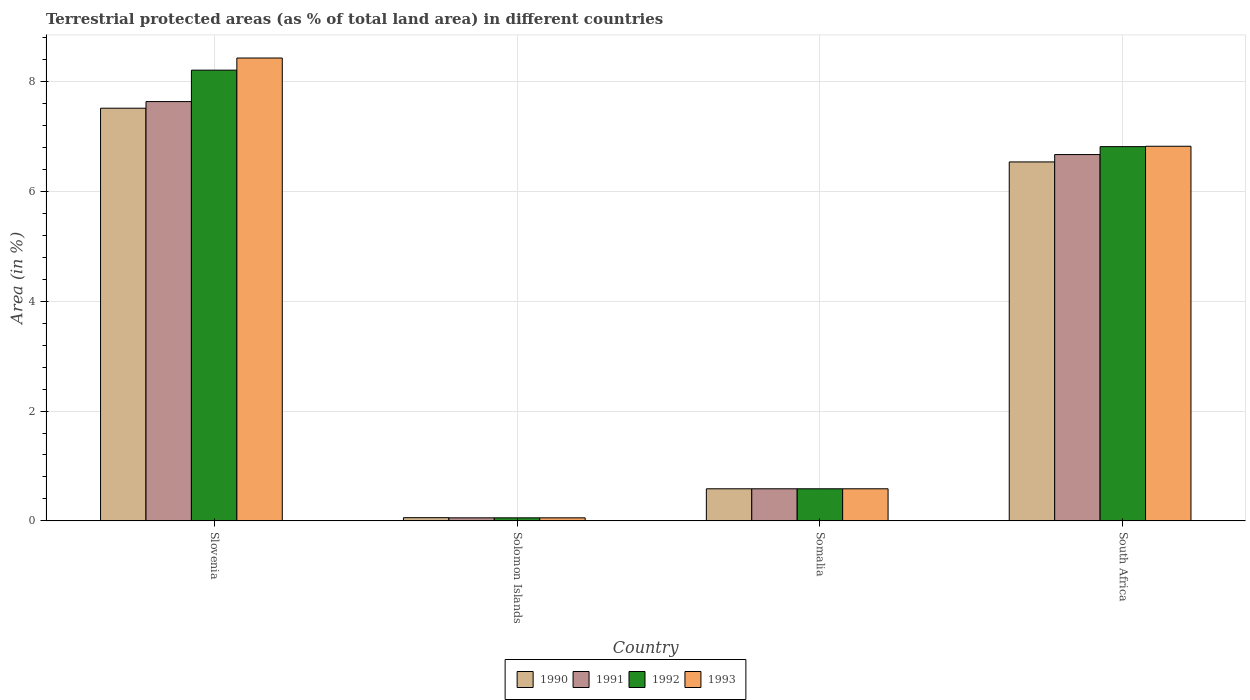How many different coloured bars are there?
Your answer should be very brief. 4. How many groups of bars are there?
Offer a very short reply. 4. Are the number of bars on each tick of the X-axis equal?
Keep it short and to the point. Yes. What is the label of the 3rd group of bars from the left?
Make the answer very short. Somalia. In how many cases, is the number of bars for a given country not equal to the number of legend labels?
Provide a short and direct response. 0. What is the percentage of terrestrial protected land in 1990 in Solomon Islands?
Make the answer very short. 0.06. Across all countries, what is the maximum percentage of terrestrial protected land in 1992?
Keep it short and to the point. 8.21. Across all countries, what is the minimum percentage of terrestrial protected land in 1993?
Provide a short and direct response. 0.05. In which country was the percentage of terrestrial protected land in 1991 maximum?
Ensure brevity in your answer.  Slovenia. In which country was the percentage of terrestrial protected land in 1990 minimum?
Provide a short and direct response. Solomon Islands. What is the total percentage of terrestrial protected land in 1992 in the graph?
Offer a terse response. 15.67. What is the difference between the percentage of terrestrial protected land in 1991 in Solomon Islands and that in Somalia?
Provide a short and direct response. -0.53. What is the difference between the percentage of terrestrial protected land in 1990 in Slovenia and the percentage of terrestrial protected land in 1992 in Solomon Islands?
Your answer should be compact. 7.46. What is the average percentage of terrestrial protected land in 1990 per country?
Give a very brief answer. 3.68. What is the difference between the percentage of terrestrial protected land of/in 1990 and percentage of terrestrial protected land of/in 1991 in Somalia?
Keep it short and to the point. 3.1764990611193866e-6. What is the ratio of the percentage of terrestrial protected land in 1992 in Solomon Islands to that in South Africa?
Provide a succinct answer. 0.01. Is the difference between the percentage of terrestrial protected land in 1990 in Slovenia and South Africa greater than the difference between the percentage of terrestrial protected land in 1991 in Slovenia and South Africa?
Your answer should be very brief. Yes. What is the difference between the highest and the second highest percentage of terrestrial protected land in 1992?
Your response must be concise. 7.63. What is the difference between the highest and the lowest percentage of terrestrial protected land in 1990?
Keep it short and to the point. 7.46. In how many countries, is the percentage of terrestrial protected land in 1992 greater than the average percentage of terrestrial protected land in 1992 taken over all countries?
Offer a very short reply. 2. Is the sum of the percentage of terrestrial protected land in 1993 in Slovenia and Solomon Islands greater than the maximum percentage of terrestrial protected land in 1991 across all countries?
Your answer should be very brief. Yes. What does the 4th bar from the left in Solomon Islands represents?
Your response must be concise. 1993. How many bars are there?
Provide a succinct answer. 16. What is the difference between two consecutive major ticks on the Y-axis?
Your response must be concise. 2. Does the graph contain any zero values?
Your answer should be very brief. No. Does the graph contain grids?
Give a very brief answer. Yes. How many legend labels are there?
Your response must be concise. 4. How are the legend labels stacked?
Provide a short and direct response. Horizontal. What is the title of the graph?
Provide a succinct answer. Terrestrial protected areas (as % of total land area) in different countries. Does "2011" appear as one of the legend labels in the graph?
Make the answer very short. No. What is the label or title of the Y-axis?
Your answer should be compact. Area (in %). What is the Area (in %) in 1990 in Slovenia?
Ensure brevity in your answer.  7.52. What is the Area (in %) of 1991 in Slovenia?
Keep it short and to the point. 7.64. What is the Area (in %) in 1992 in Slovenia?
Make the answer very short. 8.21. What is the Area (in %) of 1993 in Slovenia?
Ensure brevity in your answer.  8.43. What is the Area (in %) of 1990 in Solomon Islands?
Your answer should be compact. 0.06. What is the Area (in %) in 1991 in Solomon Islands?
Your answer should be very brief. 0.05. What is the Area (in %) of 1992 in Solomon Islands?
Your answer should be very brief. 0.05. What is the Area (in %) of 1993 in Solomon Islands?
Your answer should be compact. 0.05. What is the Area (in %) in 1990 in Somalia?
Provide a succinct answer. 0.58. What is the Area (in %) of 1991 in Somalia?
Ensure brevity in your answer.  0.58. What is the Area (in %) of 1992 in Somalia?
Offer a terse response. 0.58. What is the Area (in %) of 1993 in Somalia?
Offer a terse response. 0.58. What is the Area (in %) in 1990 in South Africa?
Offer a very short reply. 6.54. What is the Area (in %) in 1991 in South Africa?
Ensure brevity in your answer.  6.67. What is the Area (in %) of 1992 in South Africa?
Keep it short and to the point. 6.82. What is the Area (in %) in 1993 in South Africa?
Your answer should be very brief. 6.83. Across all countries, what is the maximum Area (in %) of 1990?
Provide a succinct answer. 7.52. Across all countries, what is the maximum Area (in %) in 1991?
Offer a terse response. 7.64. Across all countries, what is the maximum Area (in %) of 1992?
Provide a succinct answer. 8.21. Across all countries, what is the maximum Area (in %) of 1993?
Provide a short and direct response. 8.43. Across all countries, what is the minimum Area (in %) of 1990?
Provide a short and direct response. 0.06. Across all countries, what is the minimum Area (in %) of 1991?
Provide a short and direct response. 0.05. Across all countries, what is the minimum Area (in %) in 1992?
Make the answer very short. 0.05. Across all countries, what is the minimum Area (in %) of 1993?
Your answer should be very brief. 0.05. What is the total Area (in %) in 1990 in the graph?
Your answer should be compact. 14.7. What is the total Area (in %) in 1991 in the graph?
Your answer should be very brief. 14.95. What is the total Area (in %) in 1992 in the graph?
Your answer should be very brief. 15.67. What is the total Area (in %) of 1993 in the graph?
Provide a short and direct response. 15.9. What is the difference between the Area (in %) of 1990 in Slovenia and that in Solomon Islands?
Your answer should be very brief. 7.46. What is the difference between the Area (in %) in 1991 in Slovenia and that in Solomon Islands?
Ensure brevity in your answer.  7.58. What is the difference between the Area (in %) of 1992 in Slovenia and that in Solomon Islands?
Keep it short and to the point. 8.16. What is the difference between the Area (in %) of 1993 in Slovenia and that in Solomon Islands?
Provide a short and direct response. 8.38. What is the difference between the Area (in %) of 1990 in Slovenia and that in Somalia?
Give a very brief answer. 6.93. What is the difference between the Area (in %) of 1991 in Slovenia and that in Somalia?
Ensure brevity in your answer.  7.06. What is the difference between the Area (in %) in 1992 in Slovenia and that in Somalia?
Give a very brief answer. 7.63. What is the difference between the Area (in %) in 1993 in Slovenia and that in Somalia?
Your response must be concise. 7.85. What is the difference between the Area (in %) in 1990 in Slovenia and that in South Africa?
Provide a short and direct response. 0.98. What is the difference between the Area (in %) in 1991 in Slovenia and that in South Africa?
Provide a short and direct response. 0.97. What is the difference between the Area (in %) in 1992 in Slovenia and that in South Africa?
Provide a short and direct response. 1.39. What is the difference between the Area (in %) in 1993 in Slovenia and that in South Africa?
Keep it short and to the point. 1.61. What is the difference between the Area (in %) in 1990 in Solomon Islands and that in Somalia?
Provide a succinct answer. -0.53. What is the difference between the Area (in %) of 1991 in Solomon Islands and that in Somalia?
Provide a short and direct response. -0.53. What is the difference between the Area (in %) of 1992 in Solomon Islands and that in Somalia?
Your answer should be compact. -0.53. What is the difference between the Area (in %) in 1993 in Solomon Islands and that in Somalia?
Give a very brief answer. -0.53. What is the difference between the Area (in %) of 1990 in Solomon Islands and that in South Africa?
Give a very brief answer. -6.48. What is the difference between the Area (in %) of 1991 in Solomon Islands and that in South Africa?
Your answer should be very brief. -6.62. What is the difference between the Area (in %) in 1992 in Solomon Islands and that in South Africa?
Your answer should be very brief. -6.76. What is the difference between the Area (in %) of 1993 in Solomon Islands and that in South Africa?
Offer a very short reply. -6.77. What is the difference between the Area (in %) of 1990 in Somalia and that in South Africa?
Make the answer very short. -5.96. What is the difference between the Area (in %) of 1991 in Somalia and that in South Africa?
Your answer should be compact. -6.09. What is the difference between the Area (in %) of 1992 in Somalia and that in South Africa?
Make the answer very short. -6.23. What is the difference between the Area (in %) in 1993 in Somalia and that in South Africa?
Make the answer very short. -6.24. What is the difference between the Area (in %) of 1990 in Slovenia and the Area (in %) of 1991 in Solomon Islands?
Offer a terse response. 7.46. What is the difference between the Area (in %) in 1990 in Slovenia and the Area (in %) in 1992 in Solomon Islands?
Ensure brevity in your answer.  7.46. What is the difference between the Area (in %) of 1990 in Slovenia and the Area (in %) of 1993 in Solomon Islands?
Offer a terse response. 7.46. What is the difference between the Area (in %) in 1991 in Slovenia and the Area (in %) in 1992 in Solomon Islands?
Your answer should be compact. 7.58. What is the difference between the Area (in %) in 1991 in Slovenia and the Area (in %) in 1993 in Solomon Islands?
Your response must be concise. 7.58. What is the difference between the Area (in %) of 1992 in Slovenia and the Area (in %) of 1993 in Solomon Islands?
Offer a very short reply. 8.16. What is the difference between the Area (in %) in 1990 in Slovenia and the Area (in %) in 1991 in Somalia?
Provide a succinct answer. 6.93. What is the difference between the Area (in %) of 1990 in Slovenia and the Area (in %) of 1992 in Somalia?
Offer a very short reply. 6.93. What is the difference between the Area (in %) of 1990 in Slovenia and the Area (in %) of 1993 in Somalia?
Keep it short and to the point. 6.93. What is the difference between the Area (in %) of 1991 in Slovenia and the Area (in %) of 1992 in Somalia?
Provide a short and direct response. 7.06. What is the difference between the Area (in %) in 1991 in Slovenia and the Area (in %) in 1993 in Somalia?
Your answer should be compact. 7.06. What is the difference between the Area (in %) of 1992 in Slovenia and the Area (in %) of 1993 in Somalia?
Make the answer very short. 7.63. What is the difference between the Area (in %) in 1990 in Slovenia and the Area (in %) in 1991 in South Africa?
Your answer should be compact. 0.84. What is the difference between the Area (in %) of 1990 in Slovenia and the Area (in %) of 1993 in South Africa?
Give a very brief answer. 0.69. What is the difference between the Area (in %) of 1991 in Slovenia and the Area (in %) of 1992 in South Africa?
Provide a succinct answer. 0.82. What is the difference between the Area (in %) in 1991 in Slovenia and the Area (in %) in 1993 in South Africa?
Offer a very short reply. 0.81. What is the difference between the Area (in %) of 1992 in Slovenia and the Area (in %) of 1993 in South Africa?
Make the answer very short. 1.39. What is the difference between the Area (in %) of 1990 in Solomon Islands and the Area (in %) of 1991 in Somalia?
Your response must be concise. -0.53. What is the difference between the Area (in %) in 1990 in Solomon Islands and the Area (in %) in 1992 in Somalia?
Your answer should be very brief. -0.53. What is the difference between the Area (in %) of 1990 in Solomon Islands and the Area (in %) of 1993 in Somalia?
Your response must be concise. -0.53. What is the difference between the Area (in %) in 1991 in Solomon Islands and the Area (in %) in 1992 in Somalia?
Ensure brevity in your answer.  -0.53. What is the difference between the Area (in %) in 1991 in Solomon Islands and the Area (in %) in 1993 in Somalia?
Your answer should be very brief. -0.53. What is the difference between the Area (in %) of 1992 in Solomon Islands and the Area (in %) of 1993 in Somalia?
Your answer should be very brief. -0.53. What is the difference between the Area (in %) in 1990 in Solomon Islands and the Area (in %) in 1991 in South Africa?
Keep it short and to the point. -6.62. What is the difference between the Area (in %) of 1990 in Solomon Islands and the Area (in %) of 1992 in South Africa?
Keep it short and to the point. -6.76. What is the difference between the Area (in %) in 1990 in Solomon Islands and the Area (in %) in 1993 in South Africa?
Ensure brevity in your answer.  -6.77. What is the difference between the Area (in %) of 1991 in Solomon Islands and the Area (in %) of 1992 in South Africa?
Ensure brevity in your answer.  -6.76. What is the difference between the Area (in %) in 1991 in Solomon Islands and the Area (in %) in 1993 in South Africa?
Make the answer very short. -6.77. What is the difference between the Area (in %) in 1992 in Solomon Islands and the Area (in %) in 1993 in South Africa?
Offer a very short reply. -6.77. What is the difference between the Area (in %) in 1990 in Somalia and the Area (in %) in 1991 in South Africa?
Provide a short and direct response. -6.09. What is the difference between the Area (in %) in 1990 in Somalia and the Area (in %) in 1992 in South Africa?
Offer a very short reply. -6.23. What is the difference between the Area (in %) of 1990 in Somalia and the Area (in %) of 1993 in South Africa?
Give a very brief answer. -6.24. What is the difference between the Area (in %) in 1991 in Somalia and the Area (in %) in 1992 in South Africa?
Your answer should be very brief. -6.23. What is the difference between the Area (in %) in 1991 in Somalia and the Area (in %) in 1993 in South Africa?
Your response must be concise. -6.24. What is the difference between the Area (in %) of 1992 in Somalia and the Area (in %) of 1993 in South Africa?
Your answer should be very brief. -6.24. What is the average Area (in %) of 1990 per country?
Make the answer very short. 3.68. What is the average Area (in %) of 1991 per country?
Your response must be concise. 3.74. What is the average Area (in %) in 1992 per country?
Your answer should be compact. 3.92. What is the average Area (in %) of 1993 per country?
Your answer should be very brief. 3.97. What is the difference between the Area (in %) of 1990 and Area (in %) of 1991 in Slovenia?
Your answer should be compact. -0.12. What is the difference between the Area (in %) in 1990 and Area (in %) in 1992 in Slovenia?
Offer a terse response. -0.69. What is the difference between the Area (in %) in 1990 and Area (in %) in 1993 in Slovenia?
Provide a short and direct response. -0.91. What is the difference between the Area (in %) of 1991 and Area (in %) of 1992 in Slovenia?
Make the answer very short. -0.57. What is the difference between the Area (in %) in 1991 and Area (in %) in 1993 in Slovenia?
Give a very brief answer. -0.79. What is the difference between the Area (in %) in 1992 and Area (in %) in 1993 in Slovenia?
Keep it short and to the point. -0.22. What is the difference between the Area (in %) of 1990 and Area (in %) of 1991 in Solomon Islands?
Provide a succinct answer. 0. What is the difference between the Area (in %) in 1990 and Area (in %) in 1992 in Solomon Islands?
Provide a short and direct response. 0. What is the difference between the Area (in %) in 1990 and Area (in %) in 1993 in Solomon Islands?
Keep it short and to the point. 0. What is the difference between the Area (in %) of 1991 and Area (in %) of 1992 in Solomon Islands?
Your answer should be compact. 0. What is the difference between the Area (in %) in 1991 and Area (in %) in 1993 in Solomon Islands?
Give a very brief answer. 0. What is the difference between the Area (in %) in 1990 and Area (in %) in 1991 in Somalia?
Offer a very short reply. 0. What is the difference between the Area (in %) of 1990 and Area (in %) of 1993 in Somalia?
Your answer should be very brief. 0. What is the difference between the Area (in %) in 1991 and Area (in %) in 1992 in Somalia?
Ensure brevity in your answer.  0. What is the difference between the Area (in %) of 1990 and Area (in %) of 1991 in South Africa?
Your response must be concise. -0.13. What is the difference between the Area (in %) in 1990 and Area (in %) in 1992 in South Africa?
Your answer should be very brief. -0.28. What is the difference between the Area (in %) in 1990 and Area (in %) in 1993 in South Africa?
Provide a short and direct response. -0.29. What is the difference between the Area (in %) of 1991 and Area (in %) of 1992 in South Africa?
Your answer should be compact. -0.14. What is the difference between the Area (in %) of 1991 and Area (in %) of 1993 in South Africa?
Your answer should be very brief. -0.15. What is the difference between the Area (in %) in 1992 and Area (in %) in 1993 in South Africa?
Give a very brief answer. -0.01. What is the ratio of the Area (in %) of 1990 in Slovenia to that in Solomon Islands?
Give a very brief answer. 130.78. What is the ratio of the Area (in %) of 1991 in Slovenia to that in Solomon Islands?
Keep it short and to the point. 140.25. What is the ratio of the Area (in %) of 1992 in Slovenia to that in Solomon Islands?
Keep it short and to the point. 150.77. What is the ratio of the Area (in %) in 1993 in Slovenia to that in Solomon Islands?
Your answer should be very brief. 154.83. What is the ratio of the Area (in %) of 1990 in Slovenia to that in Somalia?
Make the answer very short. 12.87. What is the ratio of the Area (in %) of 1991 in Slovenia to that in Somalia?
Ensure brevity in your answer.  13.08. What is the ratio of the Area (in %) in 1992 in Slovenia to that in Somalia?
Make the answer very short. 14.06. What is the ratio of the Area (in %) of 1993 in Slovenia to that in Somalia?
Give a very brief answer. 14.44. What is the ratio of the Area (in %) in 1990 in Slovenia to that in South Africa?
Offer a terse response. 1.15. What is the ratio of the Area (in %) in 1991 in Slovenia to that in South Africa?
Give a very brief answer. 1.14. What is the ratio of the Area (in %) of 1992 in Slovenia to that in South Africa?
Give a very brief answer. 1.2. What is the ratio of the Area (in %) of 1993 in Slovenia to that in South Africa?
Your answer should be very brief. 1.24. What is the ratio of the Area (in %) in 1990 in Solomon Islands to that in Somalia?
Your answer should be very brief. 0.1. What is the ratio of the Area (in %) of 1991 in Solomon Islands to that in Somalia?
Your answer should be compact. 0.09. What is the ratio of the Area (in %) in 1992 in Solomon Islands to that in Somalia?
Provide a short and direct response. 0.09. What is the ratio of the Area (in %) in 1993 in Solomon Islands to that in Somalia?
Keep it short and to the point. 0.09. What is the ratio of the Area (in %) of 1990 in Solomon Islands to that in South Africa?
Give a very brief answer. 0.01. What is the ratio of the Area (in %) in 1991 in Solomon Islands to that in South Africa?
Your answer should be compact. 0.01. What is the ratio of the Area (in %) of 1992 in Solomon Islands to that in South Africa?
Offer a very short reply. 0.01. What is the ratio of the Area (in %) of 1993 in Solomon Islands to that in South Africa?
Provide a succinct answer. 0.01. What is the ratio of the Area (in %) in 1990 in Somalia to that in South Africa?
Ensure brevity in your answer.  0.09. What is the ratio of the Area (in %) of 1991 in Somalia to that in South Africa?
Offer a very short reply. 0.09. What is the ratio of the Area (in %) in 1992 in Somalia to that in South Africa?
Provide a short and direct response. 0.09. What is the ratio of the Area (in %) of 1993 in Somalia to that in South Africa?
Make the answer very short. 0.09. What is the difference between the highest and the second highest Area (in %) of 1990?
Provide a succinct answer. 0.98. What is the difference between the highest and the second highest Area (in %) in 1991?
Offer a terse response. 0.97. What is the difference between the highest and the second highest Area (in %) in 1992?
Offer a terse response. 1.39. What is the difference between the highest and the second highest Area (in %) of 1993?
Keep it short and to the point. 1.61. What is the difference between the highest and the lowest Area (in %) of 1990?
Provide a short and direct response. 7.46. What is the difference between the highest and the lowest Area (in %) in 1991?
Offer a terse response. 7.58. What is the difference between the highest and the lowest Area (in %) of 1992?
Provide a succinct answer. 8.16. What is the difference between the highest and the lowest Area (in %) in 1993?
Offer a terse response. 8.38. 